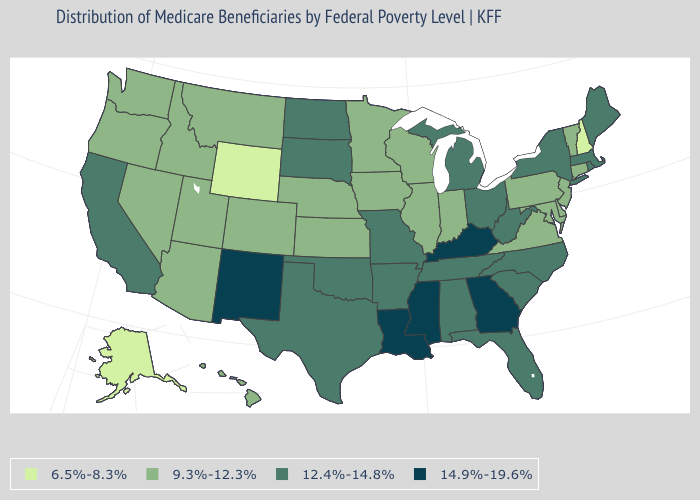Does Utah have the highest value in the West?
Concise answer only. No. Does Hawaii have a lower value than Georgia?
Keep it brief. Yes. Among the states that border Virginia , does Kentucky have the highest value?
Give a very brief answer. Yes. Which states have the lowest value in the USA?
Keep it brief. Alaska, New Hampshire, Wyoming. Which states have the lowest value in the USA?
Short answer required. Alaska, New Hampshire, Wyoming. How many symbols are there in the legend?
Be succinct. 4. What is the value of California?
Answer briefly. 12.4%-14.8%. What is the lowest value in the Northeast?
Concise answer only. 6.5%-8.3%. Is the legend a continuous bar?
Answer briefly. No. What is the highest value in the USA?
Be succinct. 14.9%-19.6%. Name the states that have a value in the range 9.3%-12.3%?
Be succinct. Arizona, Colorado, Connecticut, Delaware, Hawaii, Idaho, Illinois, Indiana, Iowa, Kansas, Maryland, Minnesota, Montana, Nebraska, Nevada, New Jersey, Oregon, Pennsylvania, Utah, Vermont, Virginia, Washington, Wisconsin. Among the states that border Montana , which have the lowest value?
Short answer required. Wyoming. Name the states that have a value in the range 6.5%-8.3%?
Quick response, please. Alaska, New Hampshire, Wyoming. Name the states that have a value in the range 6.5%-8.3%?
Concise answer only. Alaska, New Hampshire, Wyoming. Does Kentucky have the highest value in the South?
Write a very short answer. Yes. 